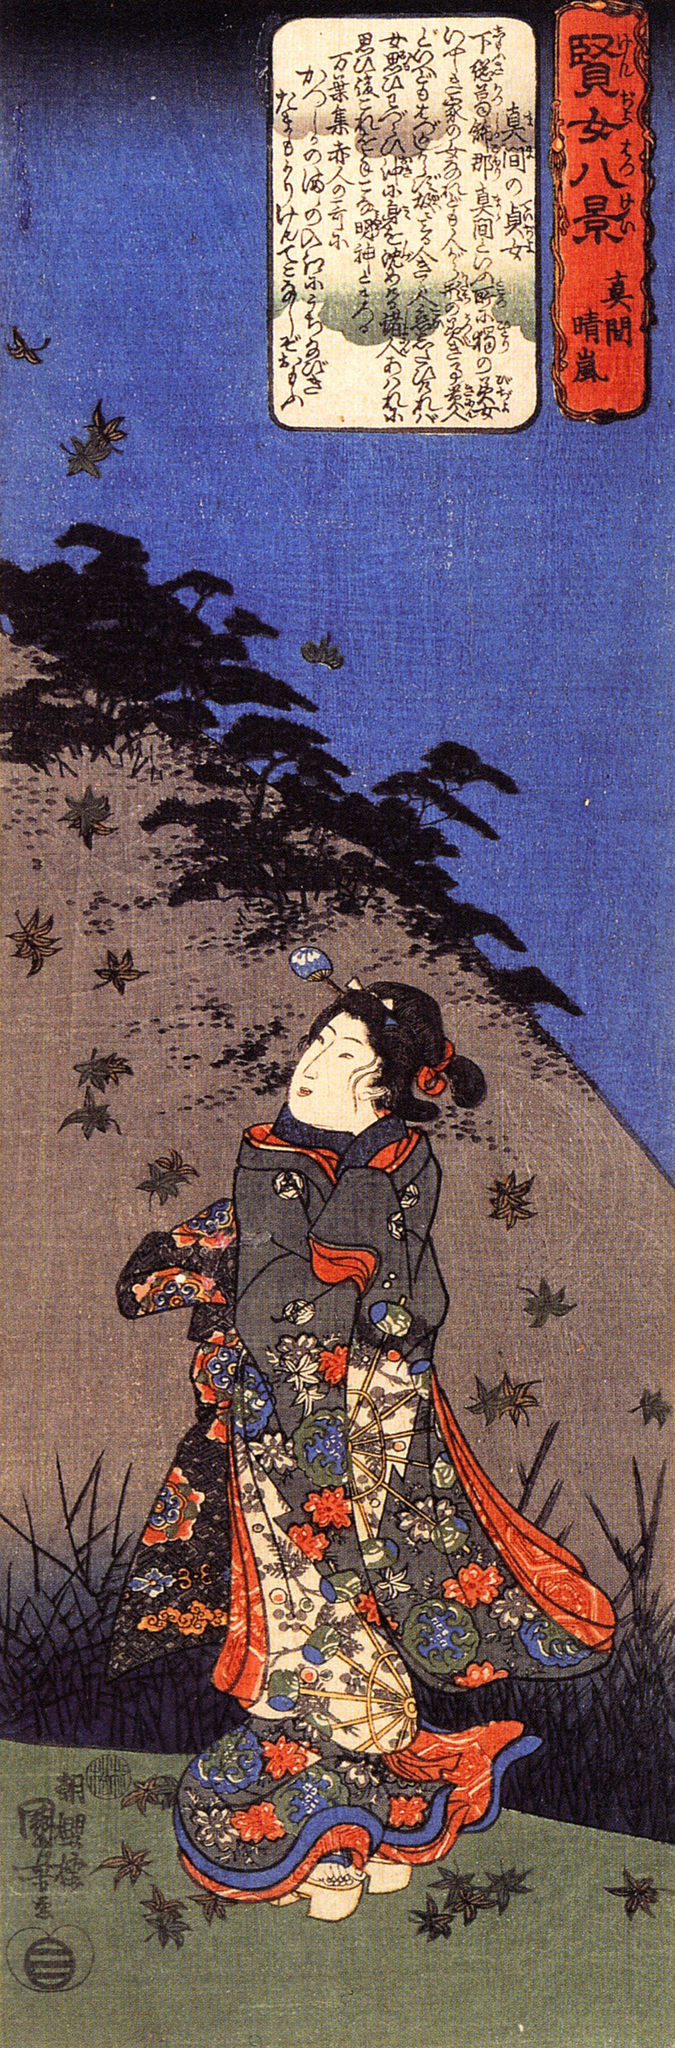Can you describe the emotions conveyed by the woman in the image? The woman in the image appears to be experiencing a mix of wonderment and contemplation. Her upward gaze suggests she is captivated by something in the sky, possibly the flock of birds or the beauty of the natural surroundings. Her expression is serene, almost dreamy, evoking a sense of peaceful admiration and reflection. The detailed patterns on her kimono and her poised stance further emphasize her elegance and grace, underscoring a deep, tranquil connection with the scene around her. 